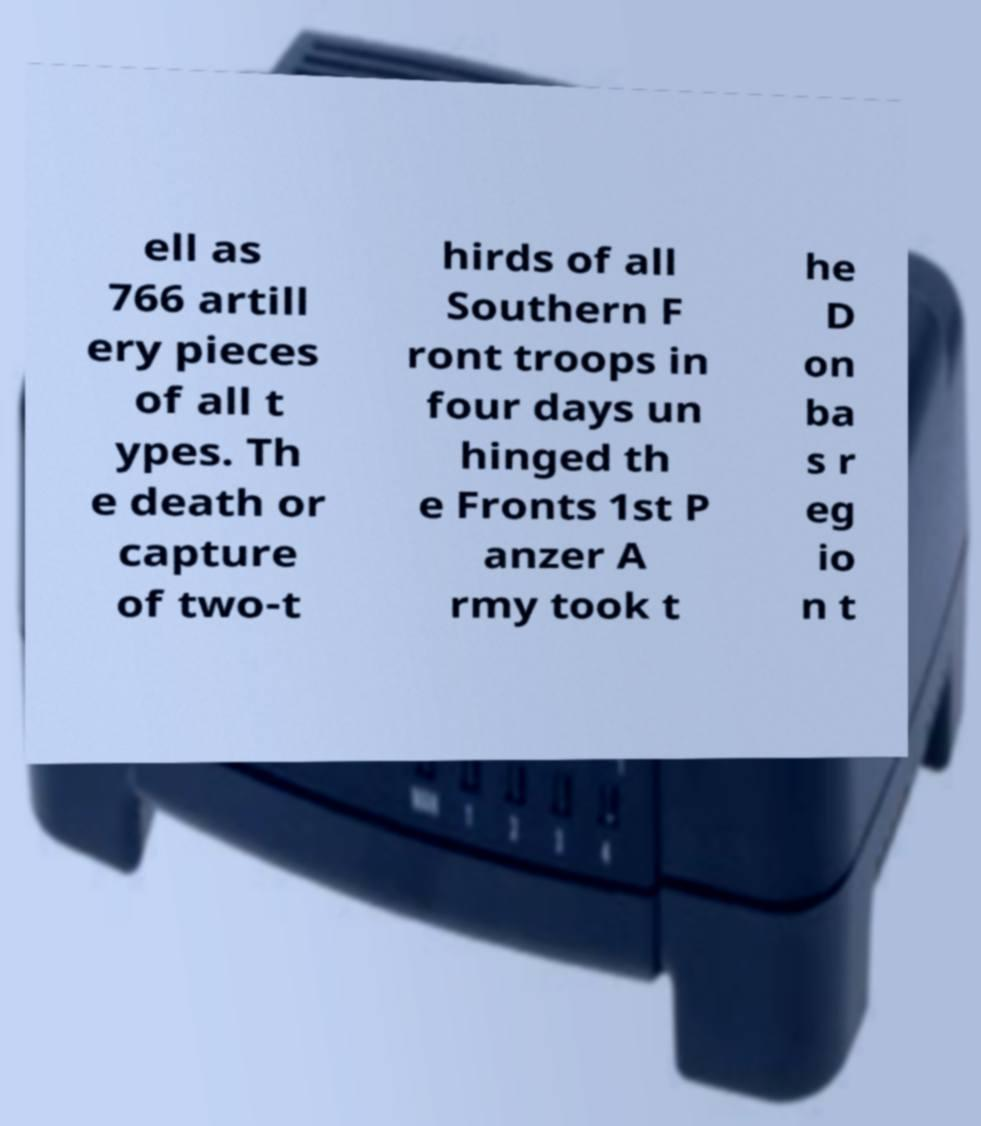What messages or text are displayed in this image? I need them in a readable, typed format. ell as 766 artill ery pieces of all t ypes. Th e death or capture of two-t hirds of all Southern F ront troops in four days un hinged th e Fronts 1st P anzer A rmy took t he D on ba s r eg io n t 